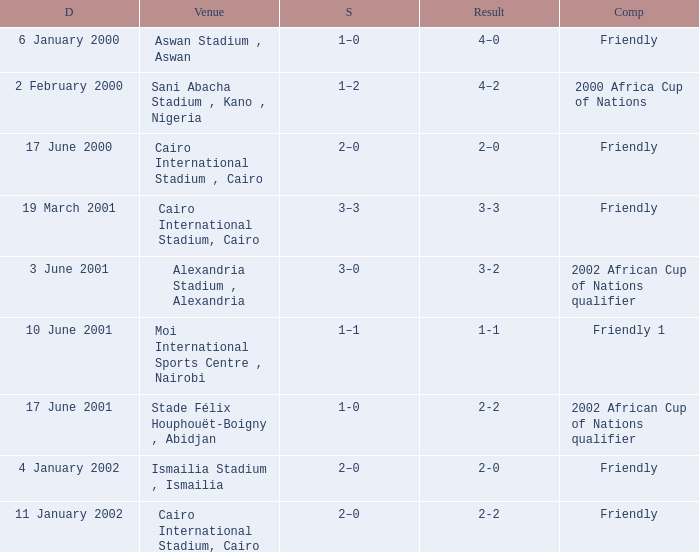What is the score of the match with a 3-2 result? 3–0. 